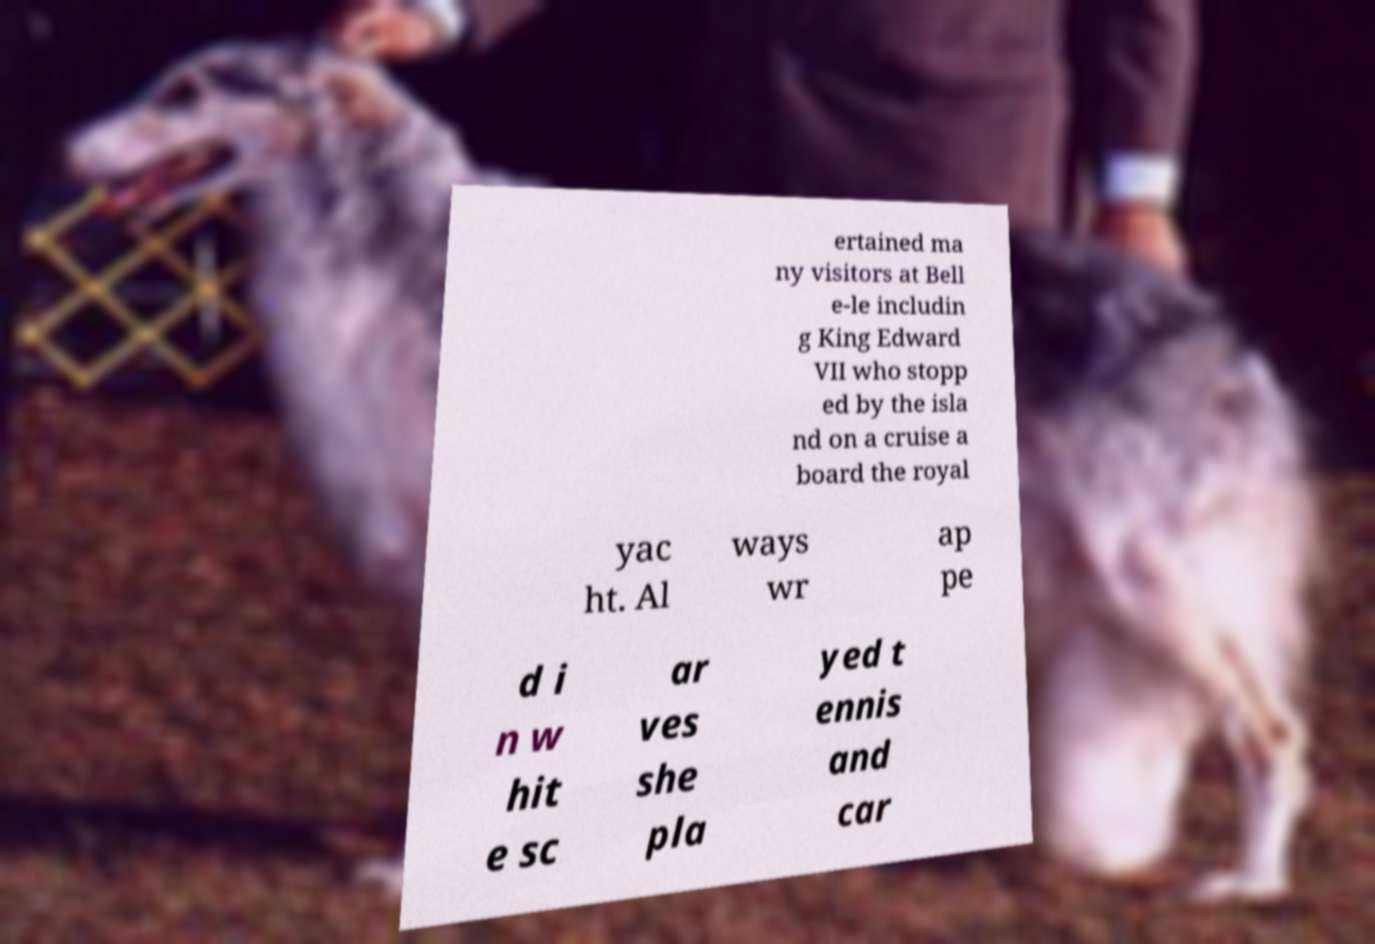What messages or text are displayed in this image? I need them in a readable, typed format. ertained ma ny visitors at Bell e-le includin g King Edward VII who stopp ed by the isla nd on a cruise a board the royal yac ht. Al ways wr ap pe d i n w hit e sc ar ves she pla yed t ennis and car 